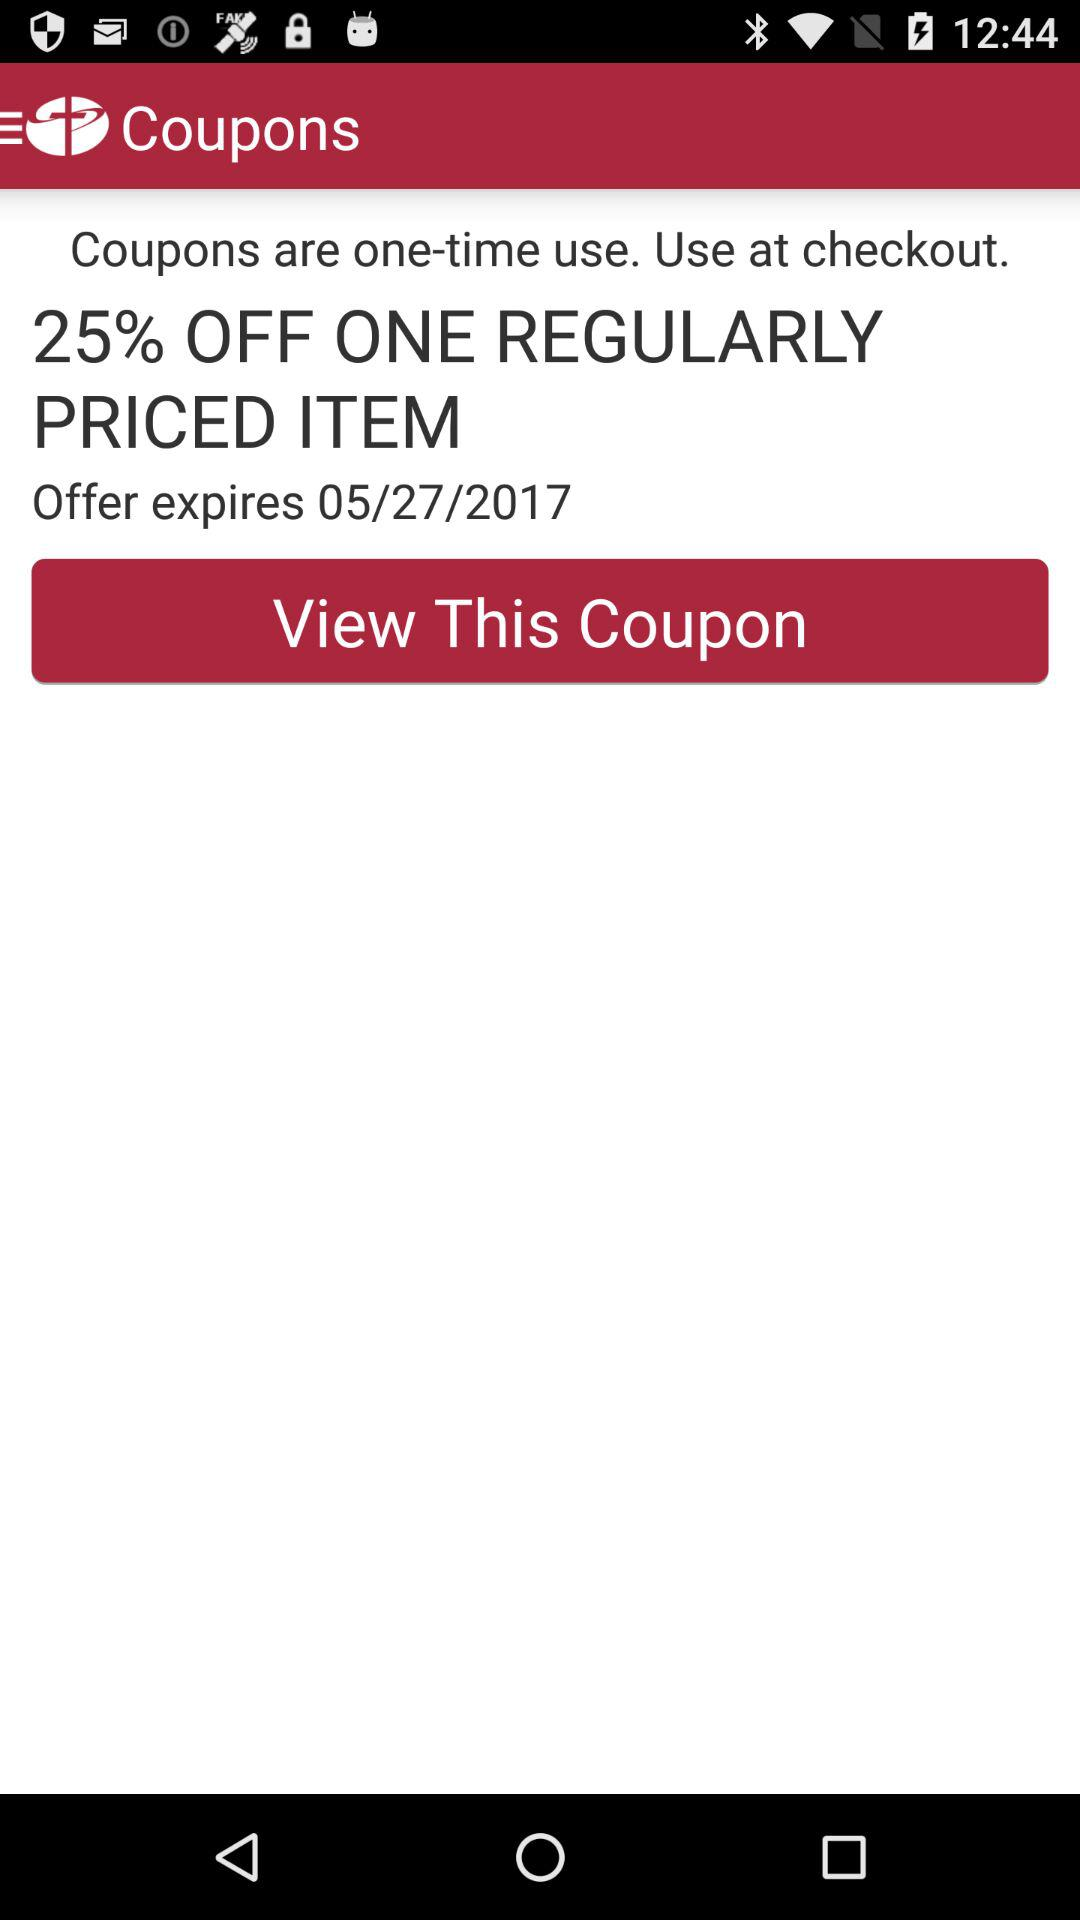How many times can we use the coupon? You can use the coupon only once. 